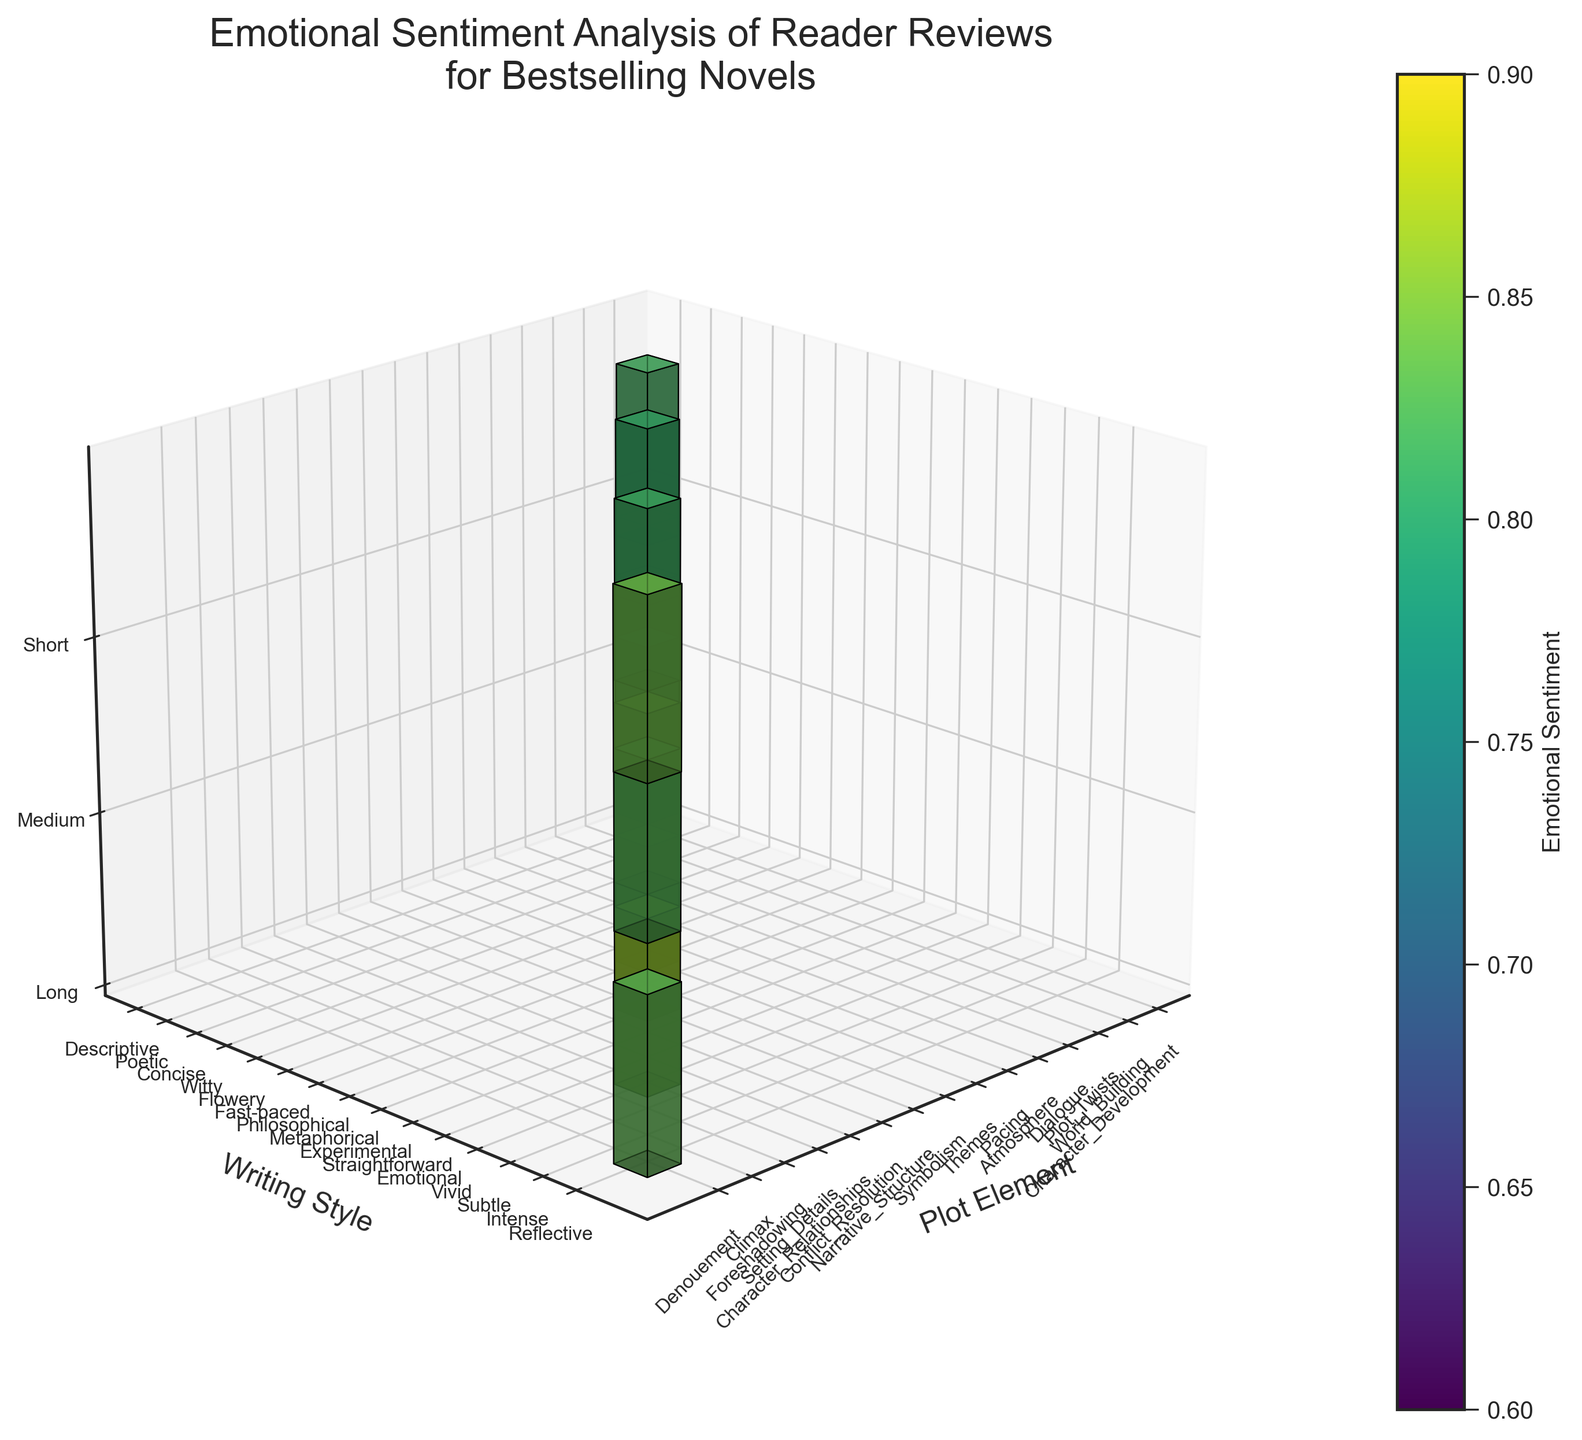How many plot elements have a high emotional sentiment rating above 0.80? To find this, look at the color intensity for the plot element axis where the color suggests a high emotional sentiment (closer to the yellow end of the viridis color map). Then count the number of those plot elements.
Answer: 6 Which plot element and writing style combination has the highest emotional sentiment in long books? Identify the voxel in the 'Long' book length section that is the brightest in color (indicating the highest sentiment), then match the coordinates to the corresponding plot element and writing style.
Answer: Dialogue and Witty What is the average emotional sentiment of medium-length books? Look at the color shades of the voxels in the 'Medium' book-length section, find the sentiment values they represent, sum them up, and then divide by the number of these voxels. The colors correspond to sentiment values given by the viridis colormap.
Answer: 0.761 Which writing style has the lowest emotional sentiment for short books? Check the 'Short' book length section, compare the sentiment levels (color shades) for different writing styles and identify the one with the darkest color.
Answer: Fast-paced How does the sentiment for 'Character Development' with a 'Descriptive' writing style in long books compare to 'Pacing' with a 'Fast-paced' style in short books? Look at the voxels corresponding to 'Character Development' and 'Pacing', compare their color intensities to determine which has higher sentiment. The brighter color in the viridis scale corresponds to a higher sentiment.
Answer: Character Development has higher sentiment 